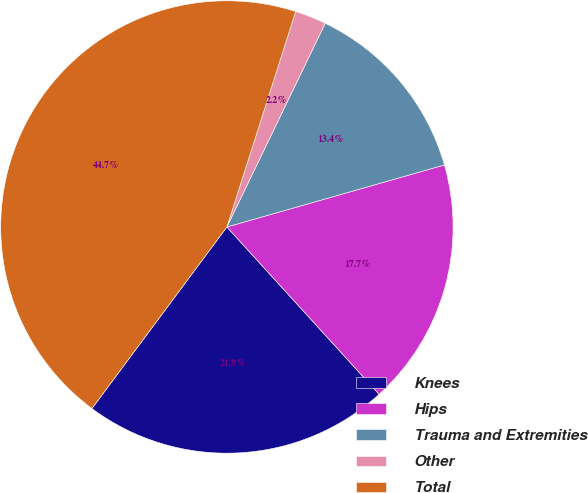Convert chart. <chart><loc_0><loc_0><loc_500><loc_500><pie_chart><fcel>Knees<fcel>Hips<fcel>Trauma and Extremities<fcel>Other<fcel>Total<nl><fcel>21.92%<fcel>17.67%<fcel>13.42%<fcel>2.24%<fcel>44.74%<nl></chart> 